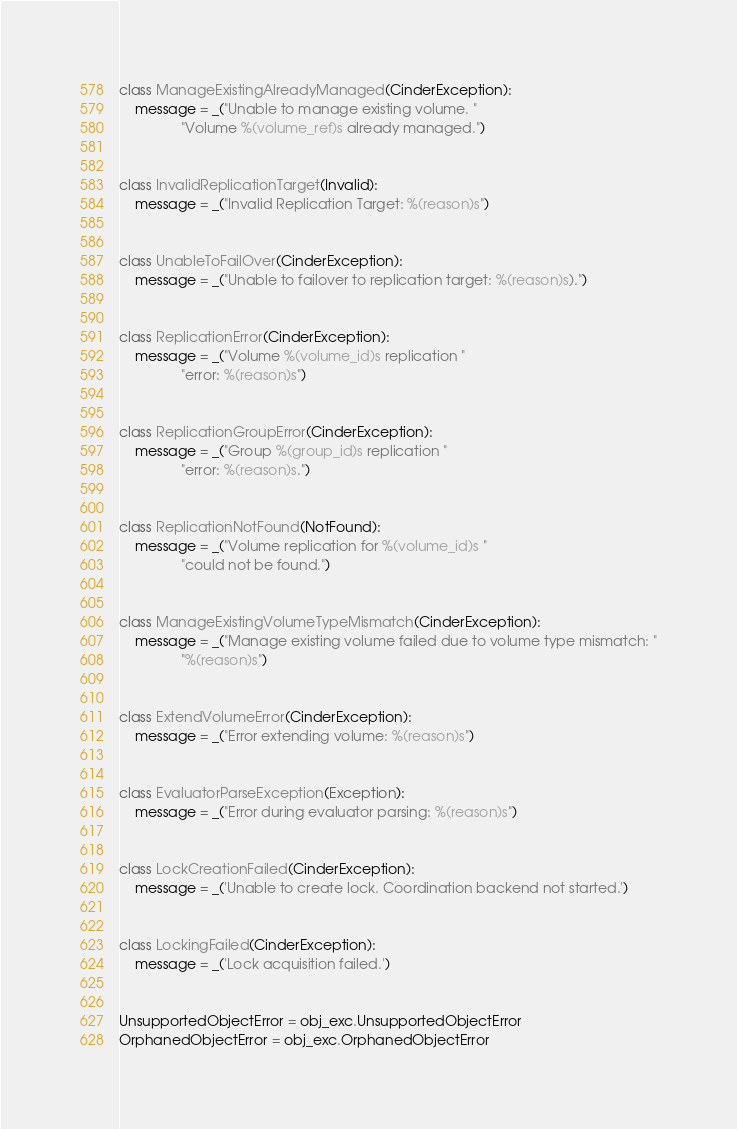<code> <loc_0><loc_0><loc_500><loc_500><_Python_>class ManageExistingAlreadyManaged(CinderException):
    message = _("Unable to manage existing volume. "
                "Volume %(volume_ref)s already managed.")


class InvalidReplicationTarget(Invalid):
    message = _("Invalid Replication Target: %(reason)s")


class UnableToFailOver(CinderException):
    message = _("Unable to failover to replication target: %(reason)s).")


class ReplicationError(CinderException):
    message = _("Volume %(volume_id)s replication "
                "error: %(reason)s")


class ReplicationGroupError(CinderException):
    message = _("Group %(group_id)s replication "
                "error: %(reason)s.")


class ReplicationNotFound(NotFound):
    message = _("Volume replication for %(volume_id)s "
                "could not be found.")


class ManageExistingVolumeTypeMismatch(CinderException):
    message = _("Manage existing volume failed due to volume type mismatch: "
                "%(reason)s")


class ExtendVolumeError(CinderException):
    message = _("Error extending volume: %(reason)s")


class EvaluatorParseException(Exception):
    message = _("Error during evaluator parsing: %(reason)s")


class LockCreationFailed(CinderException):
    message = _('Unable to create lock. Coordination backend not started.')


class LockingFailed(CinderException):
    message = _('Lock acquisition failed.')


UnsupportedObjectError = obj_exc.UnsupportedObjectError
OrphanedObjectError = obj_exc.OrphanedObjectError</code> 